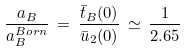<formula> <loc_0><loc_0><loc_500><loc_500>\frac { a _ { B } } { a _ { B } ^ { B o r n } } \, = \, \frac { \bar { t } _ { B } ( 0 ) } { \bar { u } _ { 2 } ( 0 ) } \, \simeq \, \frac { 1 } { 2 . 6 5 }</formula> 